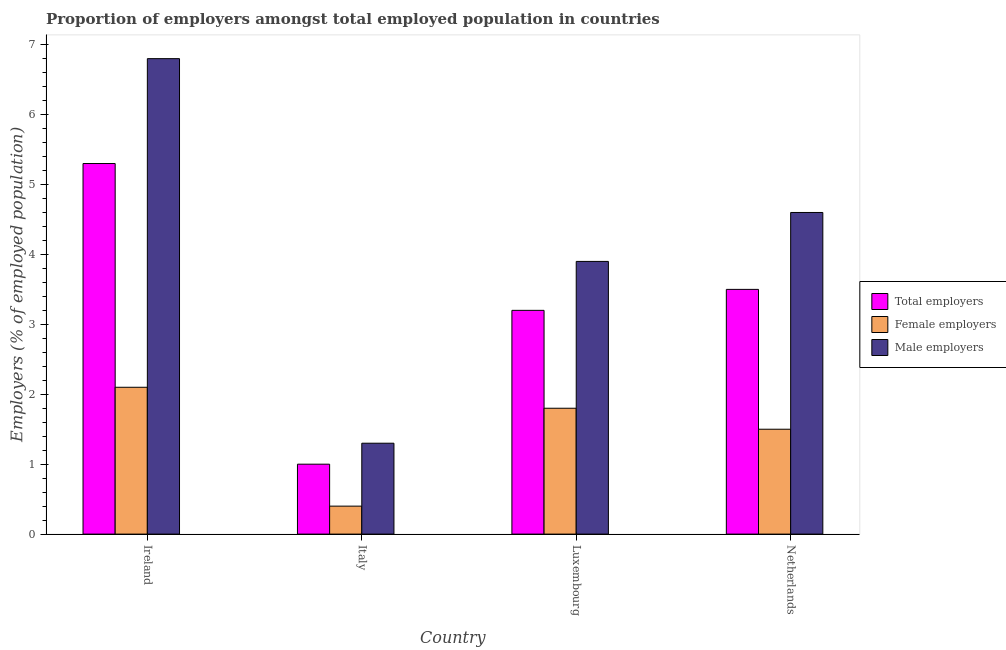How many groups of bars are there?
Give a very brief answer. 4. Are the number of bars on each tick of the X-axis equal?
Ensure brevity in your answer.  Yes. What is the percentage of female employers in Ireland?
Your answer should be very brief. 2.1. Across all countries, what is the maximum percentage of male employers?
Ensure brevity in your answer.  6.8. Across all countries, what is the minimum percentage of male employers?
Ensure brevity in your answer.  1.3. In which country was the percentage of total employers maximum?
Your response must be concise. Ireland. What is the total percentage of male employers in the graph?
Give a very brief answer. 16.6. What is the difference between the percentage of total employers in Ireland and that in Italy?
Keep it short and to the point. 4.3. What is the difference between the percentage of female employers in Luxembourg and the percentage of male employers in Ireland?
Offer a very short reply. -5. What is the average percentage of male employers per country?
Ensure brevity in your answer.  4.15. What is the difference between the percentage of male employers and percentage of total employers in Luxembourg?
Offer a very short reply. 0.7. In how many countries, is the percentage of total employers greater than 1 %?
Give a very brief answer. 3. What is the ratio of the percentage of total employers in Italy to that in Luxembourg?
Ensure brevity in your answer.  0.31. Is the percentage of female employers in Ireland less than that in Italy?
Your answer should be compact. No. What is the difference between the highest and the second highest percentage of male employers?
Make the answer very short. 2.2. What is the difference between the highest and the lowest percentage of male employers?
Your answer should be compact. 5.5. In how many countries, is the percentage of male employers greater than the average percentage of male employers taken over all countries?
Your answer should be compact. 2. What does the 3rd bar from the left in Italy represents?
Give a very brief answer. Male employers. What does the 3rd bar from the right in Italy represents?
Give a very brief answer. Total employers. Is it the case that in every country, the sum of the percentage of total employers and percentage of female employers is greater than the percentage of male employers?
Make the answer very short. Yes. How many bars are there?
Ensure brevity in your answer.  12. Are all the bars in the graph horizontal?
Your answer should be very brief. No. How many countries are there in the graph?
Ensure brevity in your answer.  4. What is the difference between two consecutive major ticks on the Y-axis?
Provide a short and direct response. 1. Are the values on the major ticks of Y-axis written in scientific E-notation?
Offer a very short reply. No. Does the graph contain grids?
Offer a terse response. No. How are the legend labels stacked?
Provide a short and direct response. Vertical. What is the title of the graph?
Provide a succinct answer. Proportion of employers amongst total employed population in countries. Does "Ages 15-20" appear as one of the legend labels in the graph?
Keep it short and to the point. No. What is the label or title of the Y-axis?
Make the answer very short. Employers (% of employed population). What is the Employers (% of employed population) of Total employers in Ireland?
Your response must be concise. 5.3. What is the Employers (% of employed population) of Female employers in Ireland?
Make the answer very short. 2.1. What is the Employers (% of employed population) in Male employers in Ireland?
Your response must be concise. 6.8. What is the Employers (% of employed population) of Total employers in Italy?
Offer a very short reply. 1. What is the Employers (% of employed population) of Female employers in Italy?
Make the answer very short. 0.4. What is the Employers (% of employed population) in Male employers in Italy?
Your response must be concise. 1.3. What is the Employers (% of employed population) of Total employers in Luxembourg?
Offer a terse response. 3.2. What is the Employers (% of employed population) of Female employers in Luxembourg?
Make the answer very short. 1.8. What is the Employers (% of employed population) in Male employers in Luxembourg?
Give a very brief answer. 3.9. What is the Employers (% of employed population) in Male employers in Netherlands?
Your answer should be compact. 4.6. Across all countries, what is the maximum Employers (% of employed population) of Total employers?
Make the answer very short. 5.3. Across all countries, what is the maximum Employers (% of employed population) in Female employers?
Offer a very short reply. 2.1. Across all countries, what is the maximum Employers (% of employed population) in Male employers?
Your answer should be compact. 6.8. Across all countries, what is the minimum Employers (% of employed population) of Total employers?
Give a very brief answer. 1. Across all countries, what is the minimum Employers (% of employed population) of Female employers?
Offer a very short reply. 0.4. Across all countries, what is the minimum Employers (% of employed population) in Male employers?
Ensure brevity in your answer.  1.3. What is the total Employers (% of employed population) in Total employers in the graph?
Offer a terse response. 13. What is the difference between the Employers (% of employed population) of Female employers in Ireland and that in Luxembourg?
Your answer should be compact. 0.3. What is the difference between the Employers (% of employed population) in Male employers in Ireland and that in Luxembourg?
Provide a succinct answer. 2.9. What is the difference between the Employers (% of employed population) of Total employers in Ireland and that in Netherlands?
Give a very brief answer. 1.8. What is the difference between the Employers (% of employed population) of Female employers in Ireland and that in Netherlands?
Provide a succinct answer. 0.6. What is the difference between the Employers (% of employed population) of Total employers in Italy and that in Luxembourg?
Your answer should be very brief. -2.2. What is the difference between the Employers (% of employed population) of Male employers in Italy and that in Luxembourg?
Keep it short and to the point. -2.6. What is the difference between the Employers (% of employed population) in Female employers in Italy and that in Netherlands?
Provide a short and direct response. -1.1. What is the difference between the Employers (% of employed population) in Male employers in Luxembourg and that in Netherlands?
Keep it short and to the point. -0.7. What is the difference between the Employers (% of employed population) of Total employers in Ireland and the Employers (% of employed population) of Male employers in Italy?
Your response must be concise. 4. What is the difference between the Employers (% of employed population) in Total employers in Ireland and the Employers (% of employed population) in Female employers in Luxembourg?
Your response must be concise. 3.5. What is the difference between the Employers (% of employed population) of Female employers in Ireland and the Employers (% of employed population) of Male employers in Luxembourg?
Keep it short and to the point. -1.8. What is the difference between the Employers (% of employed population) of Total employers in Ireland and the Employers (% of employed population) of Male employers in Netherlands?
Keep it short and to the point. 0.7. What is the difference between the Employers (% of employed population) of Female employers in Ireland and the Employers (% of employed population) of Male employers in Netherlands?
Give a very brief answer. -2.5. What is the difference between the Employers (% of employed population) of Total employers in Italy and the Employers (% of employed population) of Female employers in Netherlands?
Your answer should be compact. -0.5. What is the difference between the Employers (% of employed population) of Total employers in Italy and the Employers (% of employed population) of Male employers in Netherlands?
Make the answer very short. -3.6. What is the difference between the Employers (% of employed population) of Female employers in Luxembourg and the Employers (% of employed population) of Male employers in Netherlands?
Keep it short and to the point. -2.8. What is the average Employers (% of employed population) of Female employers per country?
Make the answer very short. 1.45. What is the average Employers (% of employed population) of Male employers per country?
Provide a succinct answer. 4.15. What is the difference between the Employers (% of employed population) of Total employers and Employers (% of employed population) of Female employers in Ireland?
Your answer should be compact. 3.2. What is the difference between the Employers (% of employed population) in Total employers and Employers (% of employed population) in Male employers in Ireland?
Your response must be concise. -1.5. What is the difference between the Employers (% of employed population) of Total employers and Employers (% of employed population) of Female employers in Luxembourg?
Your response must be concise. 1.4. What is the difference between the Employers (% of employed population) of Female employers and Employers (% of employed population) of Male employers in Luxembourg?
Offer a terse response. -2.1. What is the ratio of the Employers (% of employed population) of Female employers in Ireland to that in Italy?
Provide a succinct answer. 5.25. What is the ratio of the Employers (% of employed population) of Male employers in Ireland to that in Italy?
Offer a very short reply. 5.23. What is the ratio of the Employers (% of employed population) in Total employers in Ireland to that in Luxembourg?
Offer a terse response. 1.66. What is the ratio of the Employers (% of employed population) of Female employers in Ireland to that in Luxembourg?
Keep it short and to the point. 1.17. What is the ratio of the Employers (% of employed population) in Male employers in Ireland to that in Luxembourg?
Offer a terse response. 1.74. What is the ratio of the Employers (% of employed population) of Total employers in Ireland to that in Netherlands?
Your answer should be compact. 1.51. What is the ratio of the Employers (% of employed population) in Female employers in Ireland to that in Netherlands?
Your answer should be compact. 1.4. What is the ratio of the Employers (% of employed population) in Male employers in Ireland to that in Netherlands?
Offer a very short reply. 1.48. What is the ratio of the Employers (% of employed population) of Total employers in Italy to that in Luxembourg?
Give a very brief answer. 0.31. What is the ratio of the Employers (% of employed population) of Female employers in Italy to that in Luxembourg?
Your answer should be compact. 0.22. What is the ratio of the Employers (% of employed population) in Male employers in Italy to that in Luxembourg?
Offer a terse response. 0.33. What is the ratio of the Employers (% of employed population) of Total employers in Italy to that in Netherlands?
Provide a short and direct response. 0.29. What is the ratio of the Employers (% of employed population) in Female employers in Italy to that in Netherlands?
Your answer should be very brief. 0.27. What is the ratio of the Employers (% of employed population) of Male employers in Italy to that in Netherlands?
Make the answer very short. 0.28. What is the ratio of the Employers (% of employed population) of Total employers in Luxembourg to that in Netherlands?
Your answer should be compact. 0.91. What is the ratio of the Employers (% of employed population) in Male employers in Luxembourg to that in Netherlands?
Keep it short and to the point. 0.85. What is the difference between the highest and the second highest Employers (% of employed population) of Total employers?
Provide a succinct answer. 1.8. What is the difference between the highest and the second highest Employers (% of employed population) of Male employers?
Offer a terse response. 2.2. What is the difference between the highest and the lowest Employers (% of employed population) of Total employers?
Your answer should be very brief. 4.3. What is the difference between the highest and the lowest Employers (% of employed population) in Female employers?
Offer a terse response. 1.7. 